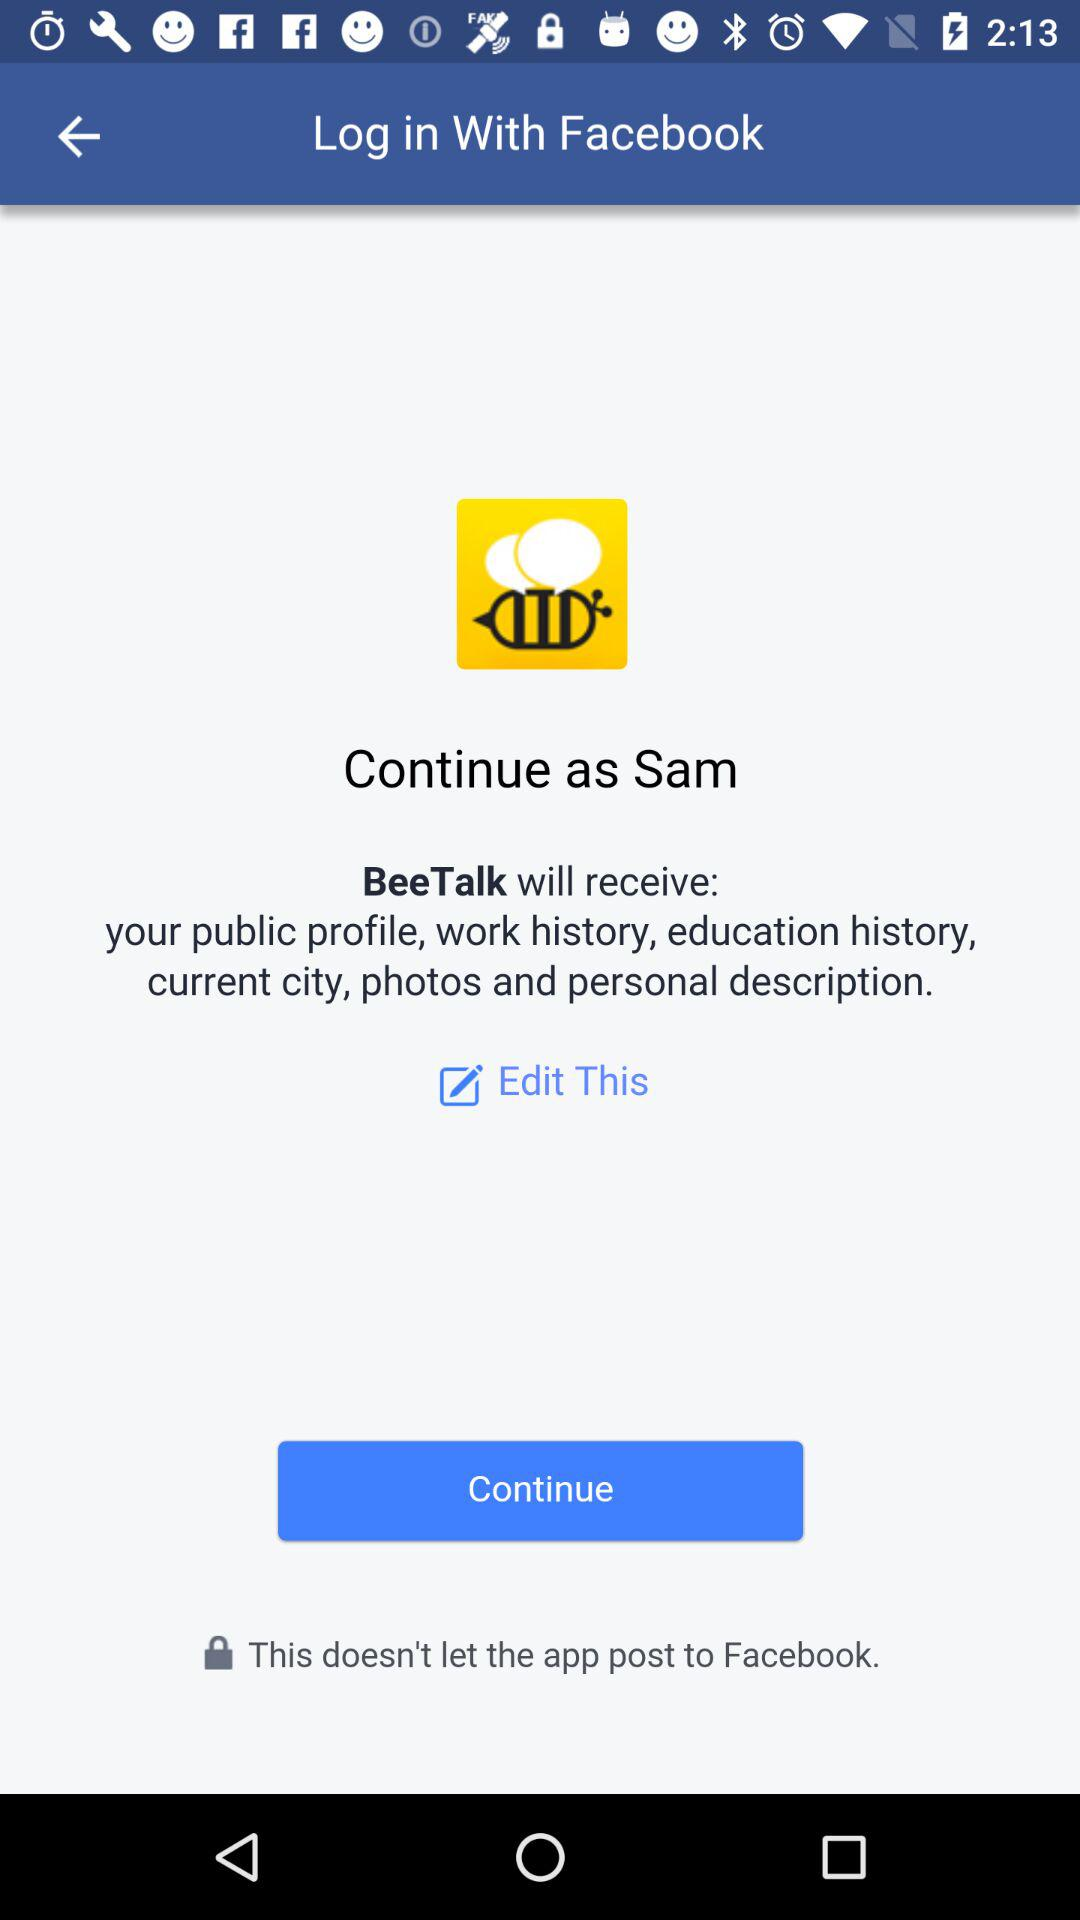What's the name of the user by whom the application can be continued? The name of the user by whom the application can be continued is Sam. 